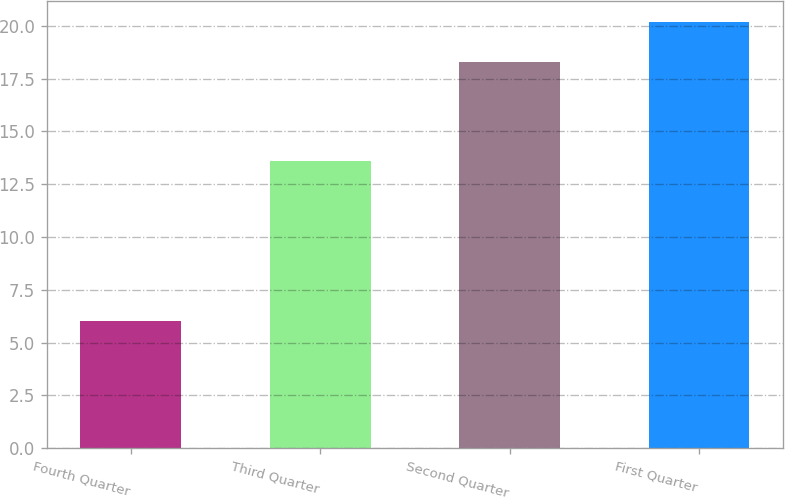<chart> <loc_0><loc_0><loc_500><loc_500><bar_chart><fcel>Fourth Quarter<fcel>Third Quarter<fcel>Second Quarter<fcel>First Quarter<nl><fcel>6<fcel>13.61<fcel>18.31<fcel>20.18<nl></chart> 